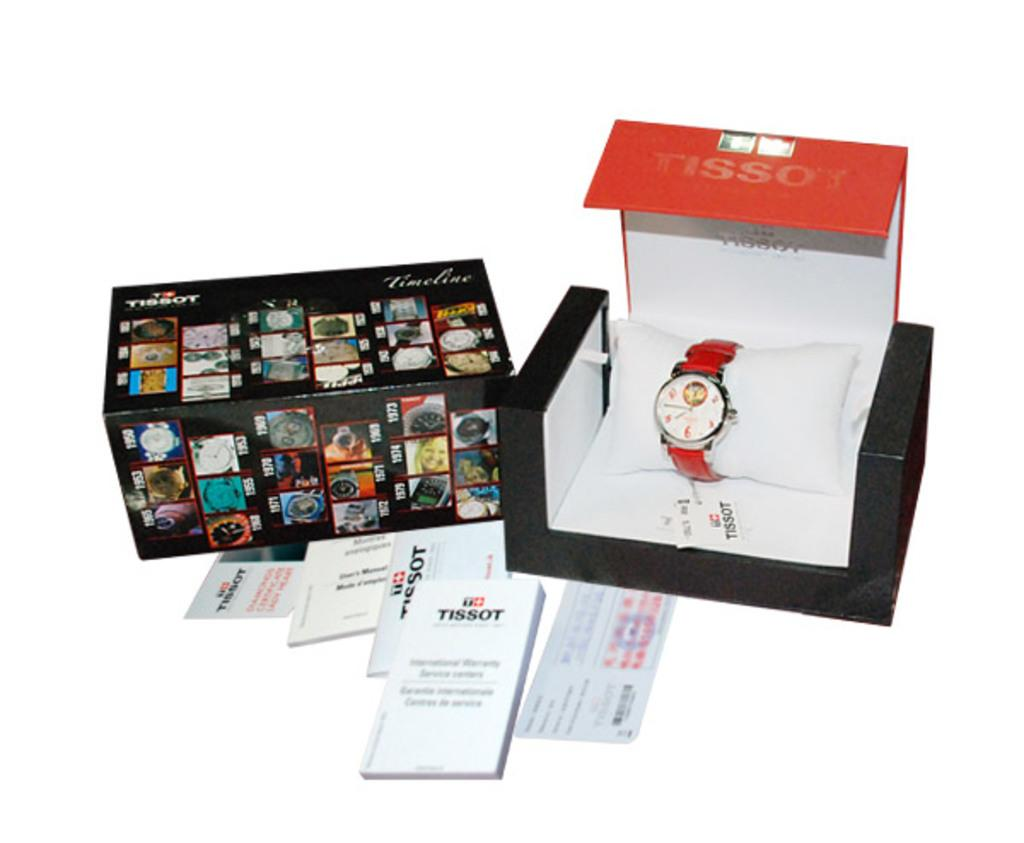<image>
Present a compact description of the photo's key features. A Tissot brand watch is displayed against a white background. 